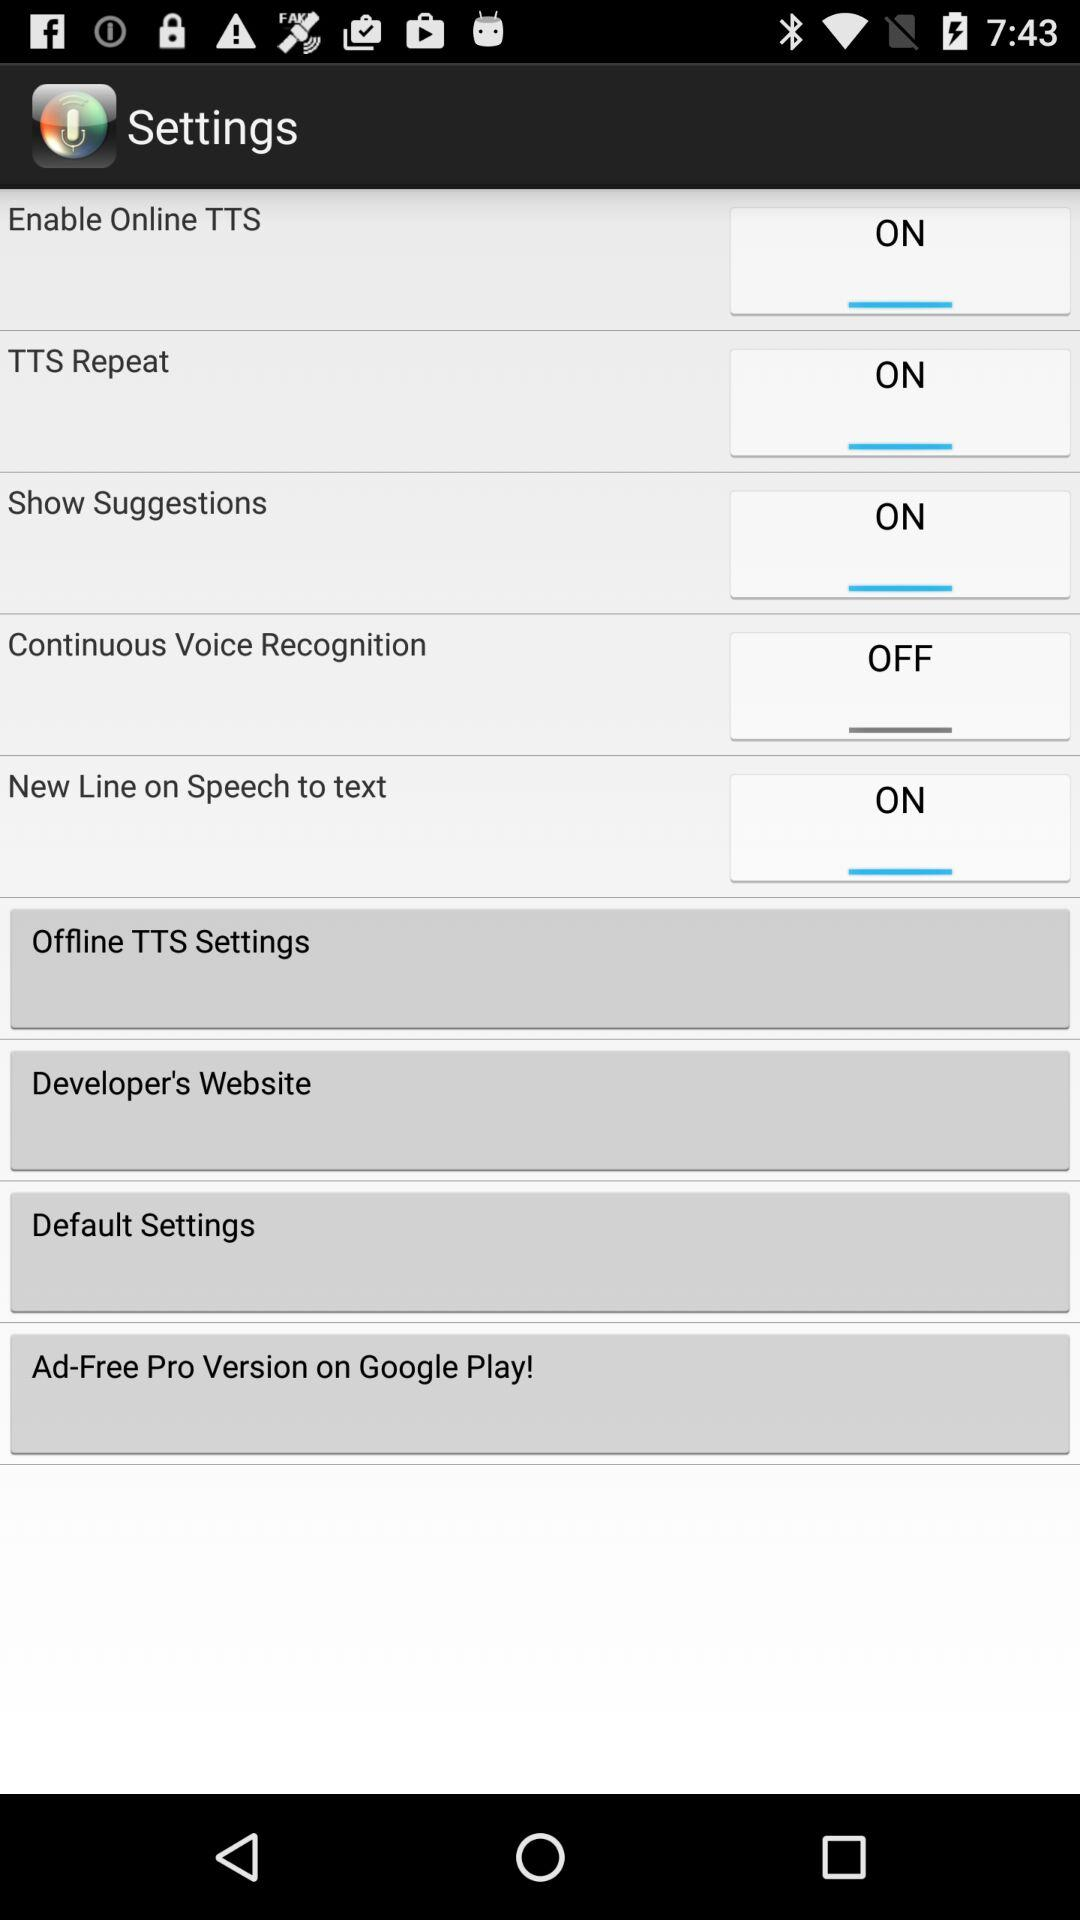What is the status of "TTS Repeat"? The status is "ON". 